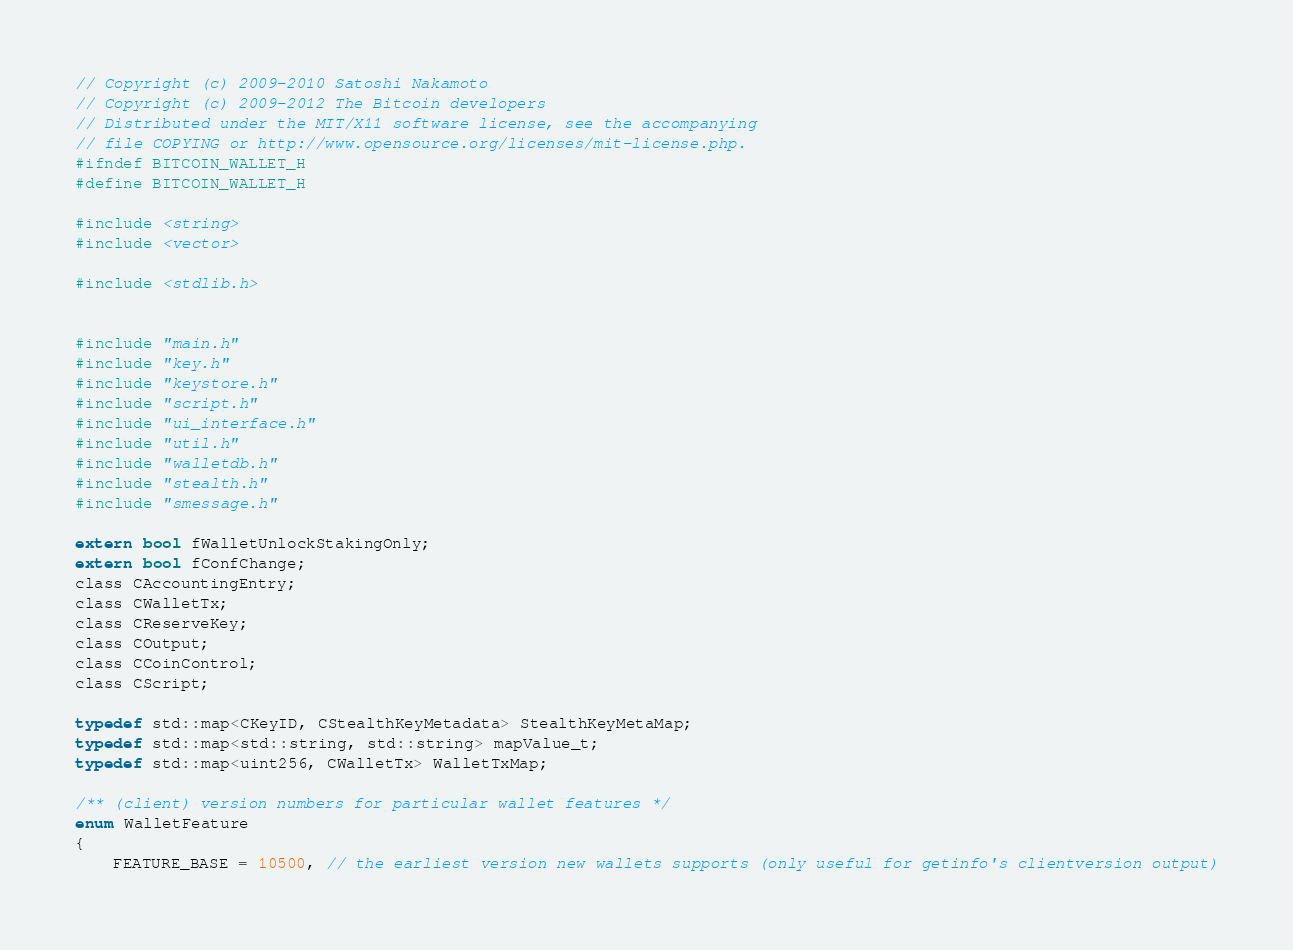<code> <loc_0><loc_0><loc_500><loc_500><_C_>// Copyright (c) 2009-2010 Satoshi Nakamoto
// Copyright (c) 2009-2012 The Bitcoin developers
// Distributed under the MIT/X11 software license, see the accompanying
// file COPYING or http://www.opensource.org/licenses/mit-license.php.
#ifndef BITCOIN_WALLET_H
#define BITCOIN_WALLET_H

#include <string>
#include <vector>

#include <stdlib.h>


#include "main.h"
#include "key.h"
#include "keystore.h"
#include "script.h"
#include "ui_interface.h"
#include "util.h"
#include "walletdb.h"
#include "stealth.h"
#include "smessage.h"

extern bool fWalletUnlockStakingOnly;
extern bool fConfChange;
class CAccountingEntry;
class CWalletTx;
class CReserveKey;
class COutput;
class CCoinControl;
class CScript;

typedef std::map<CKeyID, CStealthKeyMetadata> StealthKeyMetaMap;
typedef std::map<std::string, std::string> mapValue_t;
typedef std::map<uint256, CWalletTx> WalletTxMap;

/** (client) version numbers for particular wallet features */
enum WalletFeature
{
    FEATURE_BASE = 10500, // the earliest version new wallets supports (only useful for getinfo's clientversion output)
</code> 